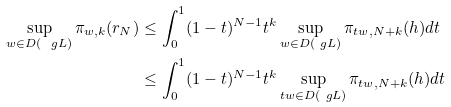<formula> <loc_0><loc_0><loc_500><loc_500>\sup _ { w \in D ( \ g L ) } \pi _ { w , k } ( r _ { N } ) & \leq \int _ { 0 } ^ { 1 } ( 1 - t ) ^ { N - 1 } t ^ { k } \sup _ { w \in D ( \ g L ) } \pi _ { t w , N + k } ( h ) d t \\ & \leq \int _ { 0 } ^ { 1 } ( 1 - t ) ^ { N - 1 } t ^ { k } \sup _ { t w \in D ( \ g L ) } \pi _ { t w , N + k } ( h ) d t</formula> 